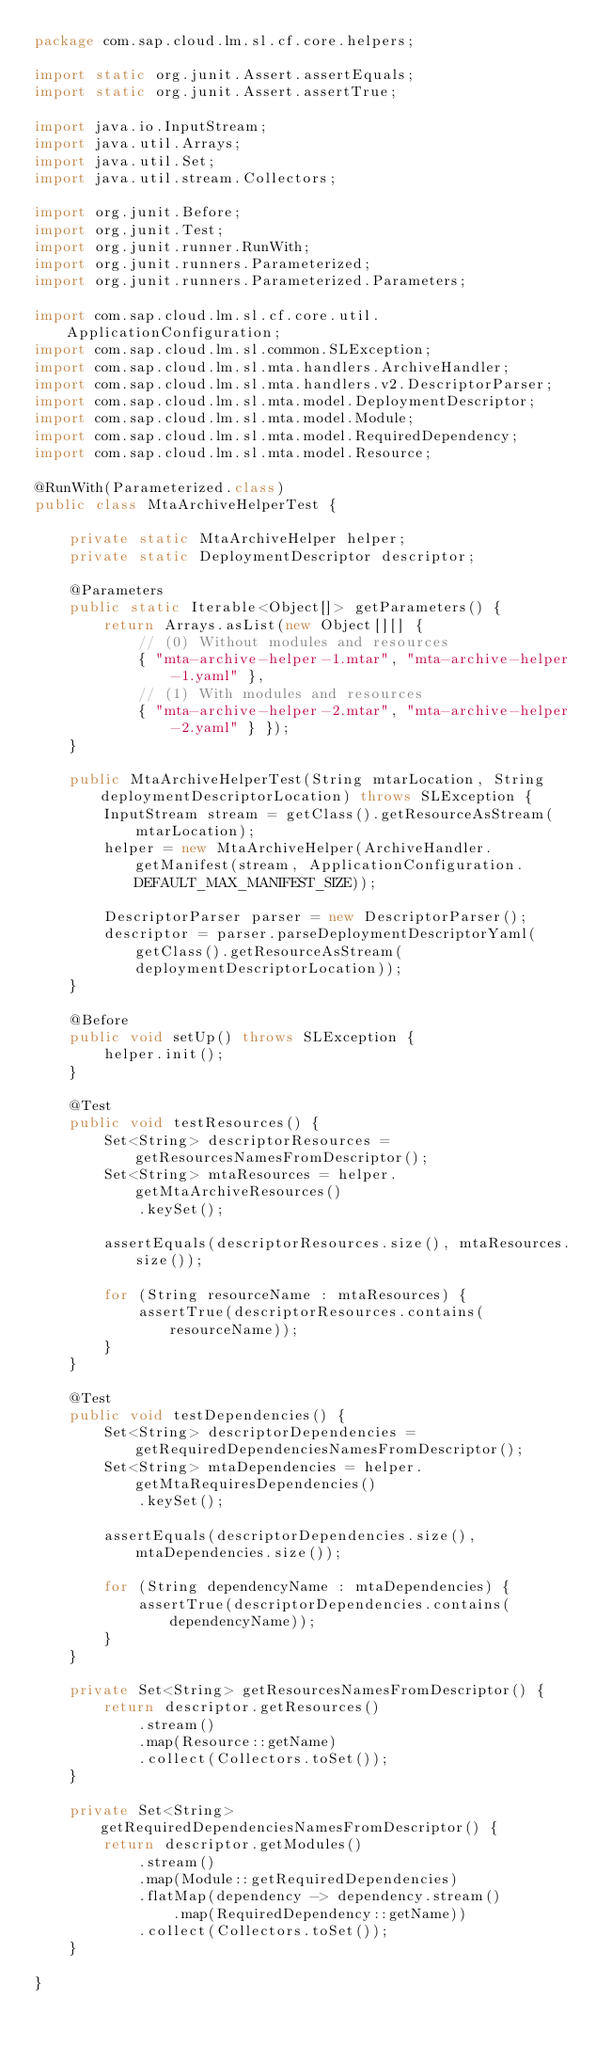Convert code to text. <code><loc_0><loc_0><loc_500><loc_500><_Java_>package com.sap.cloud.lm.sl.cf.core.helpers;

import static org.junit.Assert.assertEquals;
import static org.junit.Assert.assertTrue;

import java.io.InputStream;
import java.util.Arrays;
import java.util.Set;
import java.util.stream.Collectors;

import org.junit.Before;
import org.junit.Test;
import org.junit.runner.RunWith;
import org.junit.runners.Parameterized;
import org.junit.runners.Parameterized.Parameters;

import com.sap.cloud.lm.sl.cf.core.util.ApplicationConfiguration;
import com.sap.cloud.lm.sl.common.SLException;
import com.sap.cloud.lm.sl.mta.handlers.ArchiveHandler;
import com.sap.cloud.lm.sl.mta.handlers.v2.DescriptorParser;
import com.sap.cloud.lm.sl.mta.model.DeploymentDescriptor;
import com.sap.cloud.lm.sl.mta.model.Module;
import com.sap.cloud.lm.sl.mta.model.RequiredDependency;
import com.sap.cloud.lm.sl.mta.model.Resource;

@RunWith(Parameterized.class)
public class MtaArchiveHelperTest {

    private static MtaArchiveHelper helper;
    private static DeploymentDescriptor descriptor;

    @Parameters
    public static Iterable<Object[]> getParameters() {
        return Arrays.asList(new Object[][] {
            // (0) Without modules and resources
            { "mta-archive-helper-1.mtar", "mta-archive-helper-1.yaml" },
            // (1) With modules and resources
            { "mta-archive-helper-2.mtar", "mta-archive-helper-2.yaml" } });
    }

    public MtaArchiveHelperTest(String mtarLocation, String deploymentDescriptorLocation) throws SLException {
        InputStream stream = getClass().getResourceAsStream(mtarLocation);
        helper = new MtaArchiveHelper(ArchiveHandler.getManifest(stream, ApplicationConfiguration.DEFAULT_MAX_MANIFEST_SIZE));

        DescriptorParser parser = new DescriptorParser();
        descriptor = parser.parseDeploymentDescriptorYaml(getClass().getResourceAsStream(deploymentDescriptorLocation));
    }

    @Before
    public void setUp() throws SLException {
        helper.init();
    }

    @Test
    public void testResources() {
        Set<String> descriptorResources = getResourcesNamesFromDescriptor();
        Set<String> mtaResources = helper.getMtaArchiveResources()
            .keySet();

        assertEquals(descriptorResources.size(), mtaResources.size());

        for (String resourceName : mtaResources) {
            assertTrue(descriptorResources.contains(resourceName));
        }
    }

    @Test
    public void testDependencies() {
        Set<String> descriptorDependencies = getRequiredDependenciesNamesFromDescriptor();
        Set<String> mtaDependencies = helper.getMtaRequiresDependencies()
            .keySet();

        assertEquals(descriptorDependencies.size(), mtaDependencies.size());

        for (String dependencyName : mtaDependencies) {
            assertTrue(descriptorDependencies.contains(dependencyName));
        }
    }

    private Set<String> getResourcesNamesFromDescriptor() {
        return descriptor.getResources()
            .stream()
            .map(Resource::getName)
            .collect(Collectors.toSet());
    }

    private Set<String> getRequiredDependenciesNamesFromDescriptor() {
        return descriptor.getModules()
            .stream()
            .map(Module::getRequiredDependencies)
            .flatMap(dependency -> dependency.stream()
                .map(RequiredDependency::getName))
            .collect(Collectors.toSet());
    }

}
</code> 